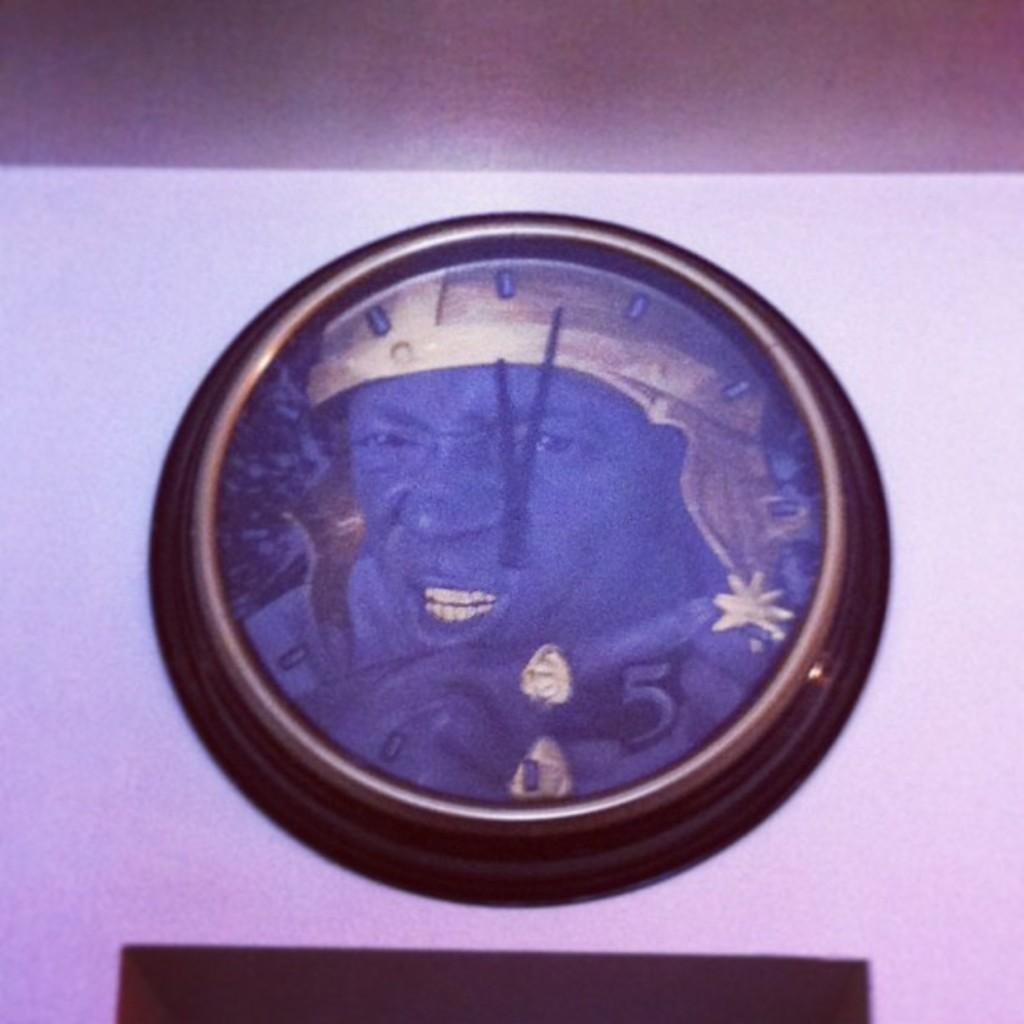What object is present in the image that displays time? There is a clock in the image. Where is the clock located in the image? The clock is attached to the wall. What is the amount of quartz visible in the image? There is no quartz present in the image. What type of skirt is the clock wearing in the image? The clock is not a person and does not wear clothing, so it is not wearing a skirt in the image. 